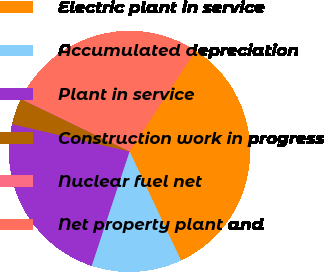<chart> <loc_0><loc_0><loc_500><loc_500><pie_chart><fcel>Electric plant in service<fcel>Accumulated depreciation<fcel>Plant in service<fcel>Construction work in progress<fcel>Nuclear fuel net<fcel>Net property plant and<nl><fcel>33.73%<fcel>12.11%<fcel>23.54%<fcel>3.54%<fcel>0.19%<fcel>26.89%<nl></chart> 